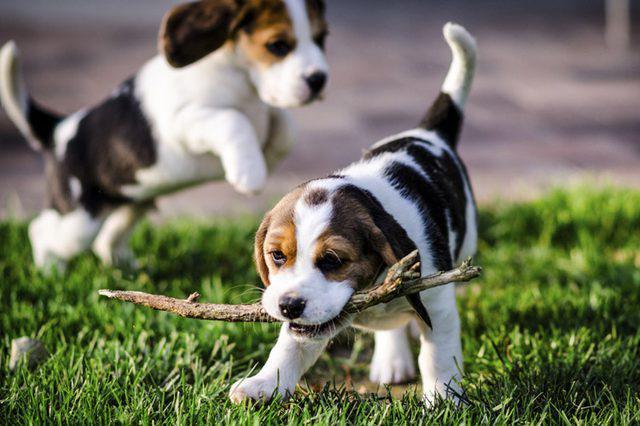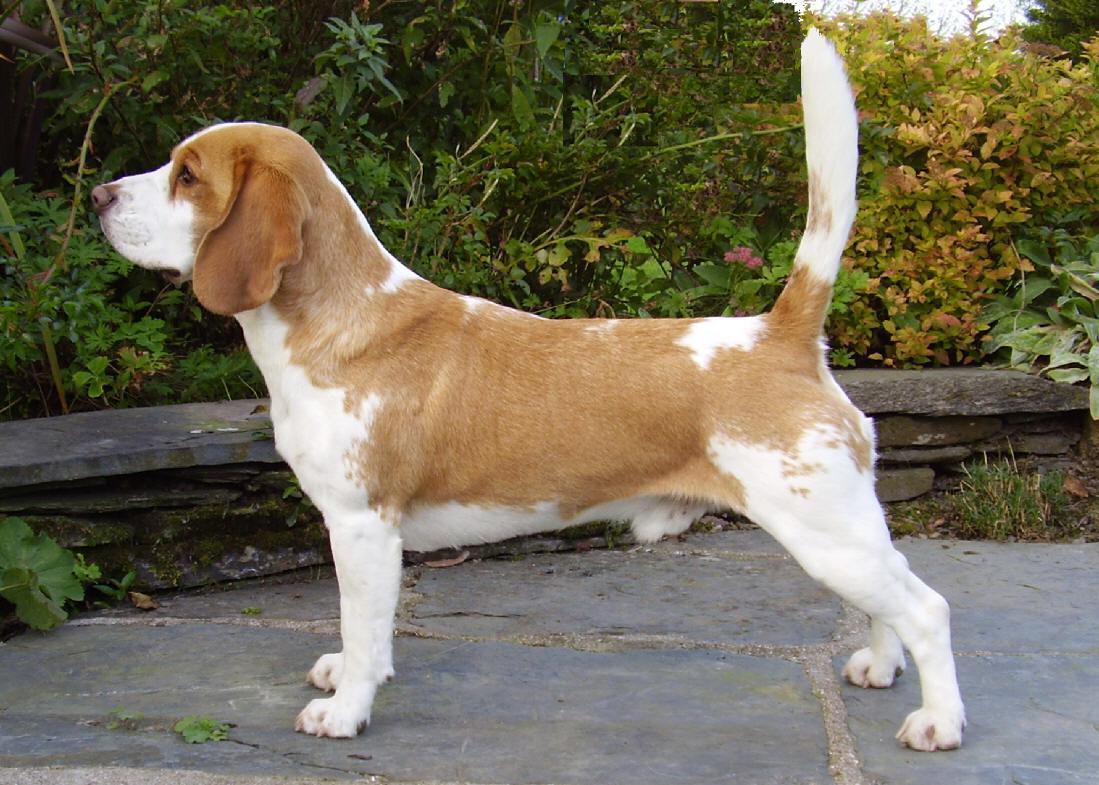The first image is the image on the left, the second image is the image on the right. For the images shown, is this caption "Each image contains one beagle standing on all fours with its tail up, and the beagle on the right wears a red collar." true? Answer yes or no. No. The first image is the image on the left, the second image is the image on the right. Given the left and right images, does the statement "There is at least two dogs in the left image." hold true? Answer yes or no. Yes. 